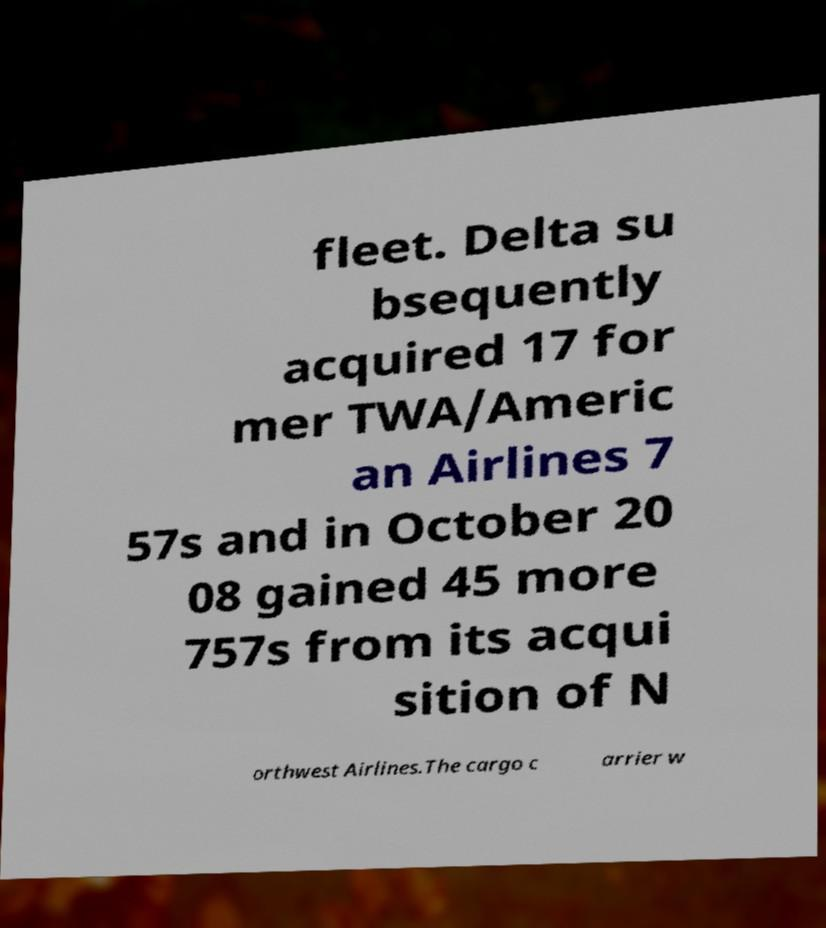There's text embedded in this image that I need extracted. Can you transcribe it verbatim? fleet. Delta su bsequently acquired 17 for mer TWA/Americ an Airlines 7 57s and in October 20 08 gained 45 more 757s from its acqui sition of N orthwest Airlines.The cargo c arrier w 